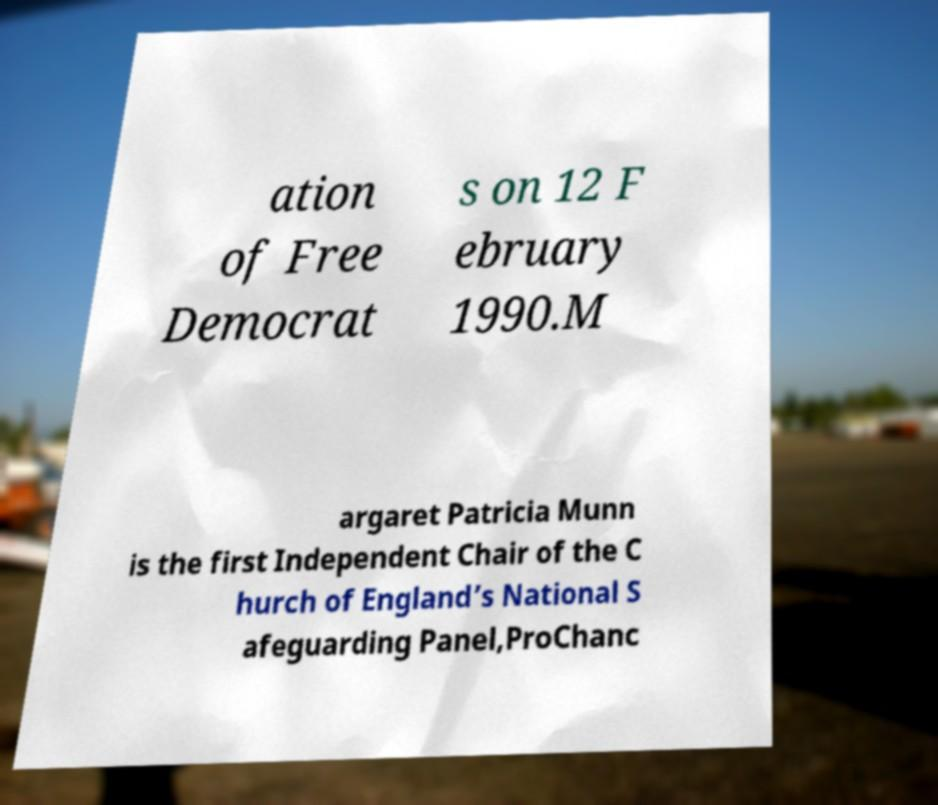Can you accurately transcribe the text from the provided image for me? ation of Free Democrat s on 12 F ebruary 1990.M argaret Patricia Munn is the first Independent Chair of the C hurch of England’s National S afeguarding Panel,ProChanc 